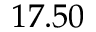Convert formula to latex. <formula><loc_0><loc_0><loc_500><loc_500>1 7 . 5 0</formula> 